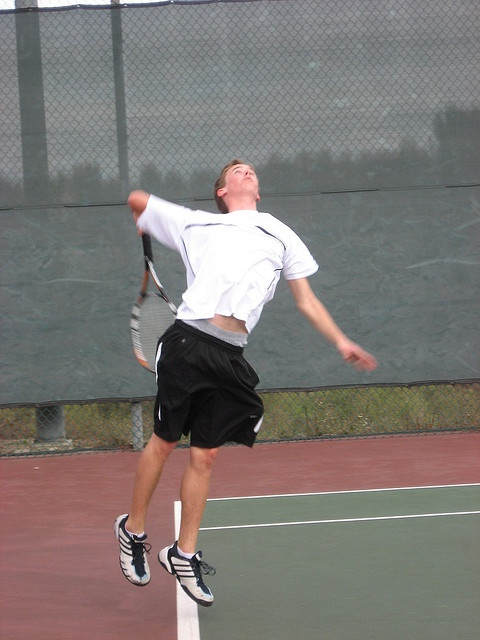Describe the objects in this image and their specific colors. I can see people in white, black, salmon, and lightpink tones and tennis racket in white, gray, black, and lightgray tones in this image. 